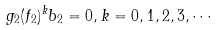<formula> <loc_0><loc_0><loc_500><loc_500>g _ { 2 } ( f _ { 2 } ) ^ { k } b _ { 2 } = 0 , k = 0 , 1 , 2 , 3 , \cdots</formula> 